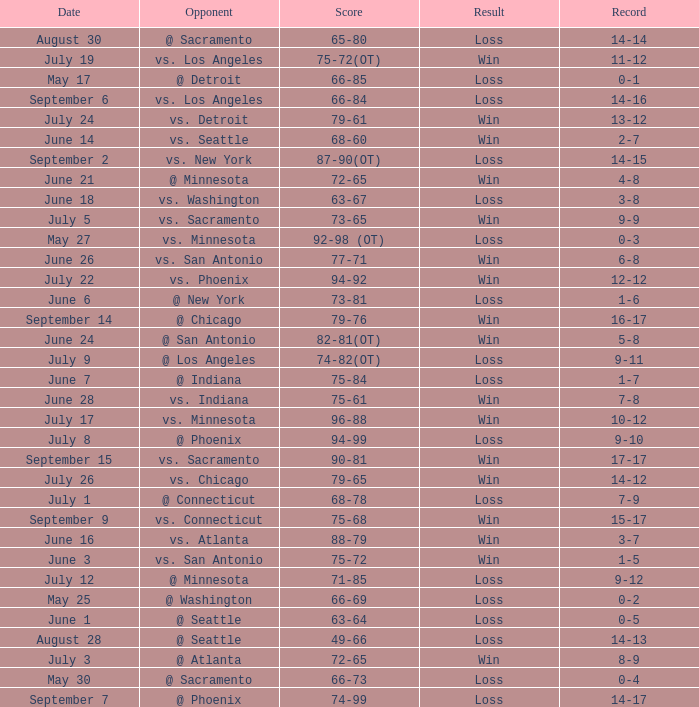What was the Score of the game with a Record of 0-1? 66-85. 